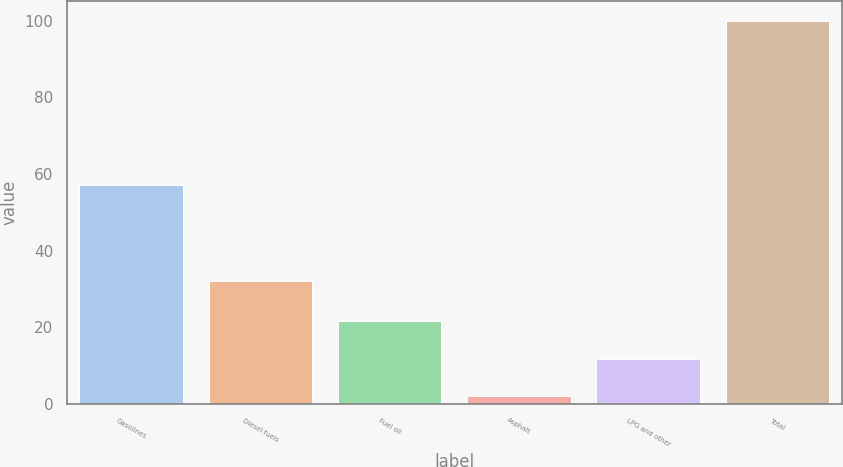Convert chart to OTSL. <chart><loc_0><loc_0><loc_500><loc_500><bar_chart><fcel>Gasolines<fcel>Diesel fuels<fcel>Fuel oil<fcel>Asphalt<fcel>LPG and other<fcel>Total<nl><fcel>57<fcel>32<fcel>21.6<fcel>2<fcel>11.8<fcel>100<nl></chart> 